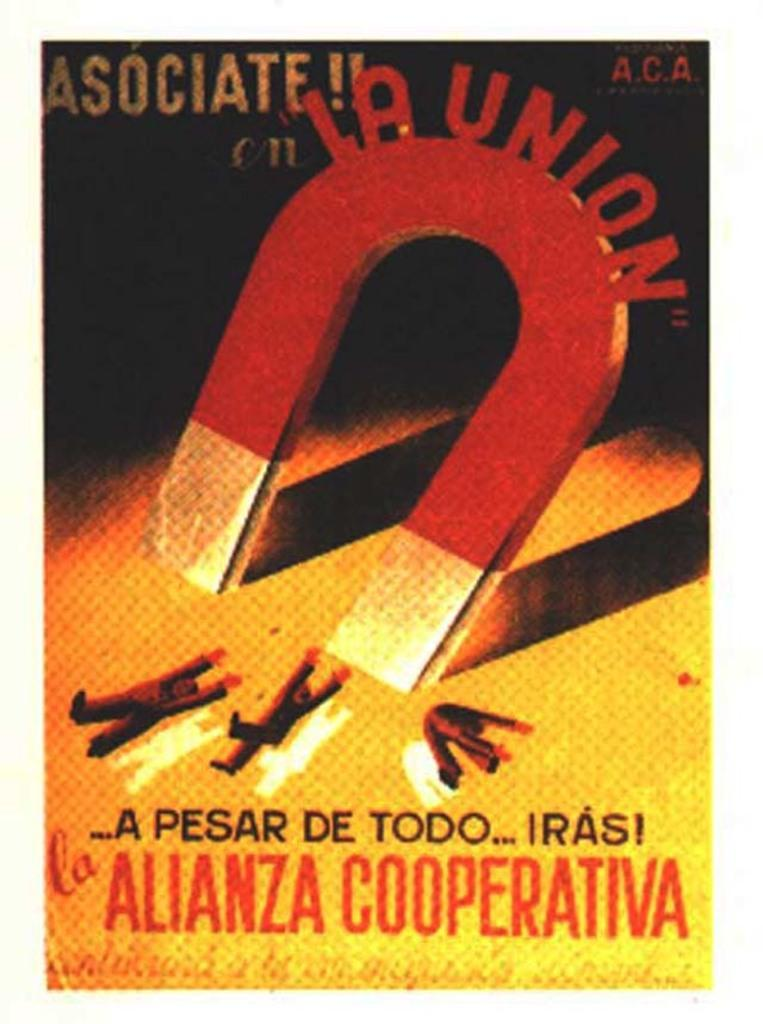Provide a one-sentence caption for the provided image. A poster that features a painting of a large magnet and includes the text "la union". 